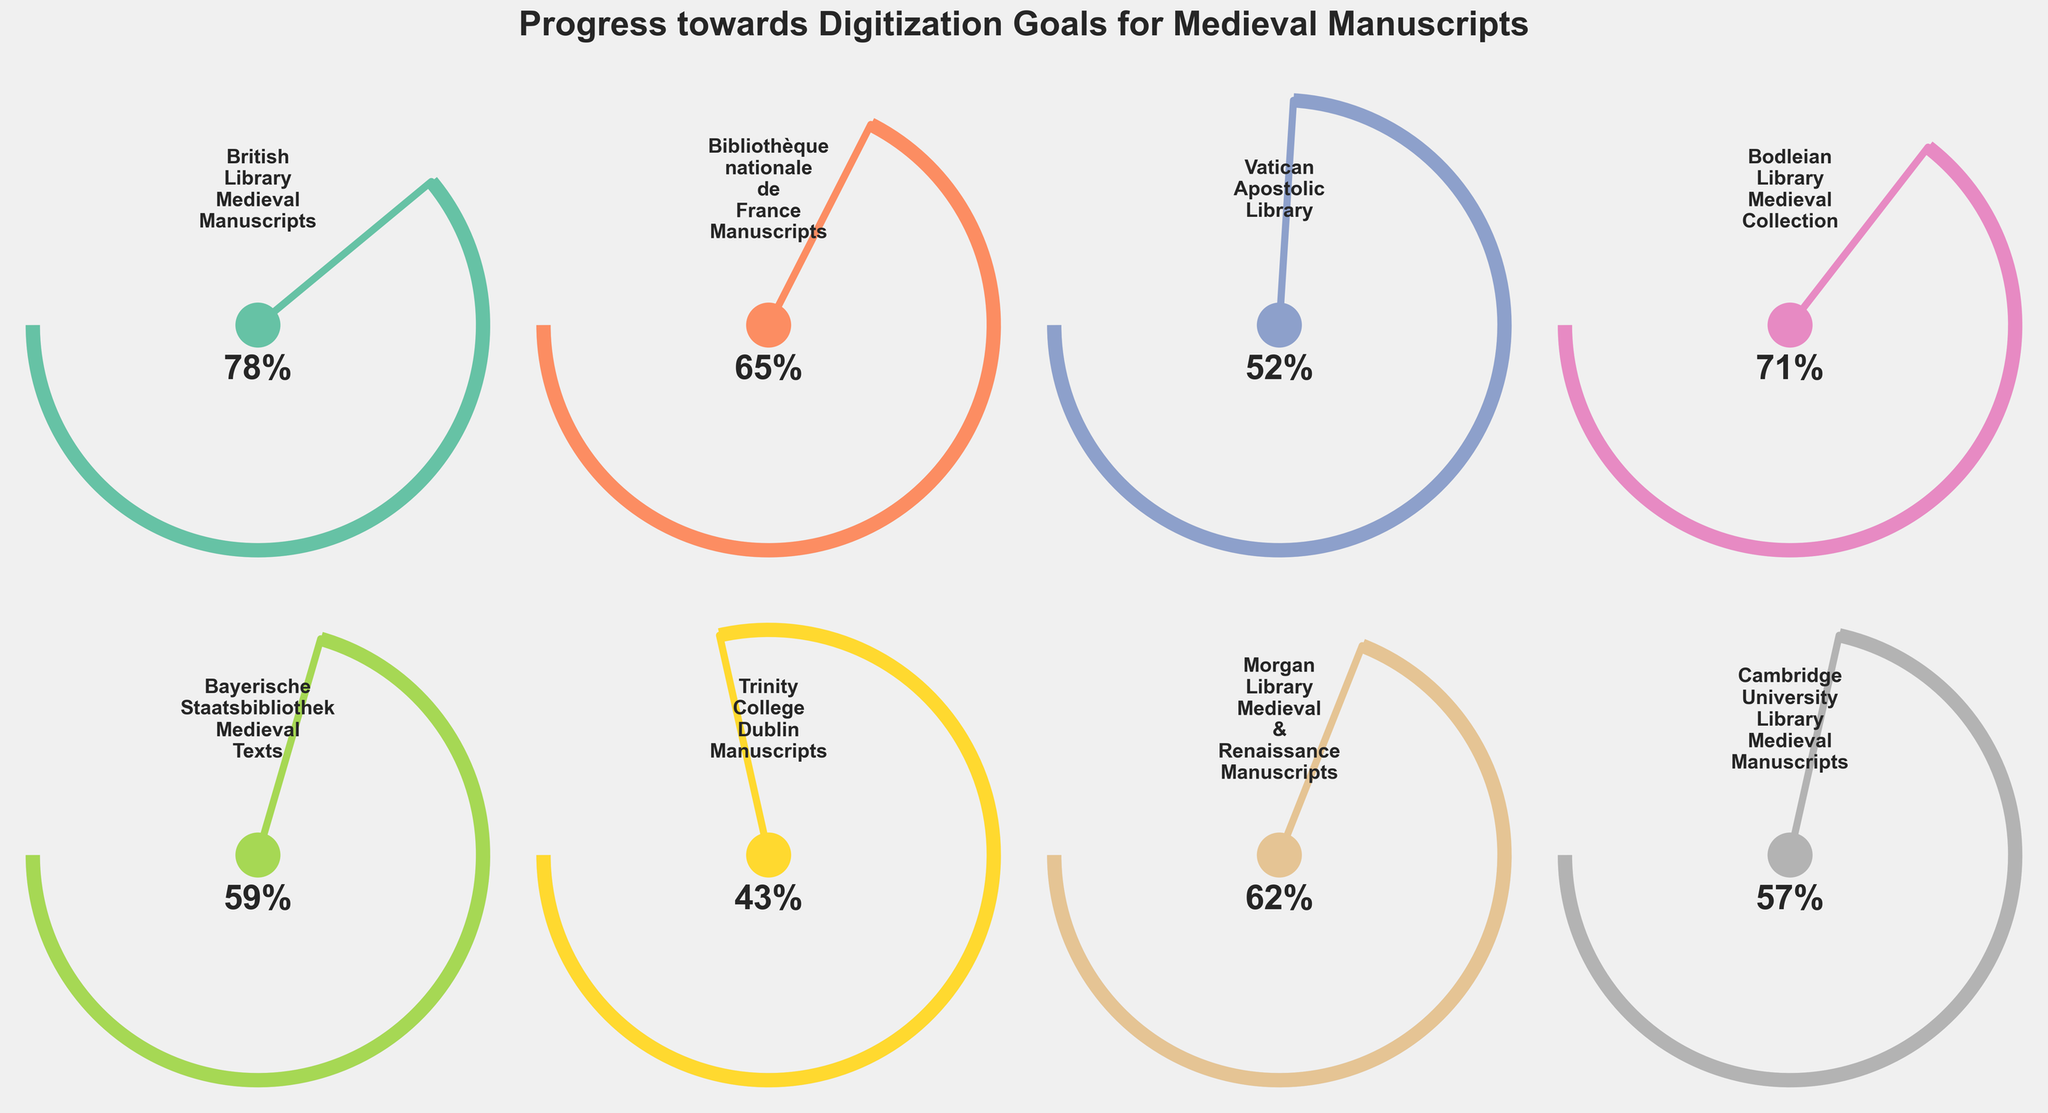Which library has the highest digitization progress? The British Library Medieval Manuscripts have the highest digitization progress at 78%, as seen by their gauge displaying the highest percentage.
Answer: British Library Medieval Manuscripts What is the average digitization progress of all the listed projects? To find the average, sum the digitization percentages (78+65+52+71+59+43+62+57) and then divide by the number of projects (8). The calculation is (78+65+52+71+59+43+62+57) / 8 = 487 / 8 = 60.875%.
Answer: 60.875% Which projects have digitization progress greater than 60%? By examining the displayed percentages on each gauge, the projects with progress greater than 60% are the British Library Medieval Manuscripts (78%), Bibliothèque nationale de France Manuscripts (65%), Bodleian Library Medieval Collection (71%), and Morgan Library Medieval & Renaissance Manuscripts (62%).
Answer: British Library, Bibliothèque nationale de France, Bodleian Library, Morgan Library How much more progress has the project with the highest digitization made compared to the project with the lowest digitization? The project with the highest digitization is the British Library Medieval Manuscripts at 78%, and the project with the lowest is Trinity College Dublin Manuscripts at 43%. The difference is calculated as 78% - 43% = 35%.
Answer: 35% What is the median digitization progress of the projects? Arrange the digitization percentages in ascending order (43, 52, 57, 59, 62, 65, 71, 78). With eight data points, the median is the average of the 4th and 5th values: (59 + 62) / 2 = 60.5%.
Answer: 60.5% Which project is closest to achieving 50% digitization progress? By examining the gauges, the Vatican Apostolic Library is closest to 50% digitization progress at 52%.
Answer: Vatican Apostolic Library Which libraries have a digitization progress within 5% of each other? Identifying pairs with close digitization progress by examining the gauges, we find that Morgan Library Medieval & Renaissance Manuscripts (62%) and Bibliothèque nationale de France Manuscripts (65%) have a progress difference of 3%, and Bodleian Library Medieval Collection (71%) and British Library Medieval Manuscripts (78%) have a progress difference of 7%, within 5% if rounding is applied.
Answer: Morgan Library & Bibliothèque nationale de France, Bodleian Library & British Library What's the total digitization progress combined for these projects? Summing up the digitization percentages of all these projects (78+65+52+71+59+43+62+57), we get a total digitization progress percentage of 487%.
Answer: 487% 